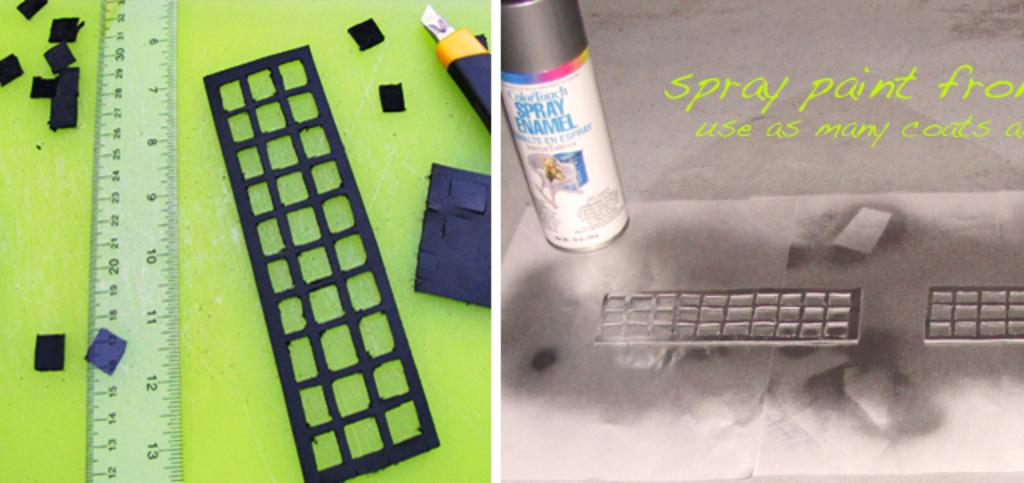<image>
Give a short and clear explanation of the subsequent image. A can of ColorTouch Spray Enamel is being used with a stencil and ruler. 